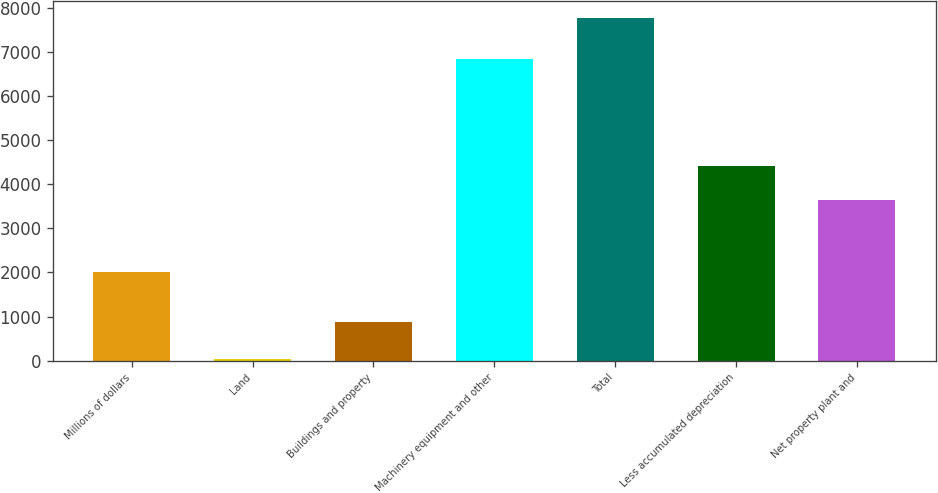<chart> <loc_0><loc_0><loc_500><loc_500><bar_chart><fcel>Millions of dollars<fcel>Land<fcel>Buildings and property<fcel>Machinery equipment and other<fcel>Total<fcel>Less accumulated depreciation<fcel>Net property plant and<nl><fcel>2007<fcel>46<fcel>869<fcel>6841<fcel>7756<fcel>4401<fcel>3630<nl></chart> 